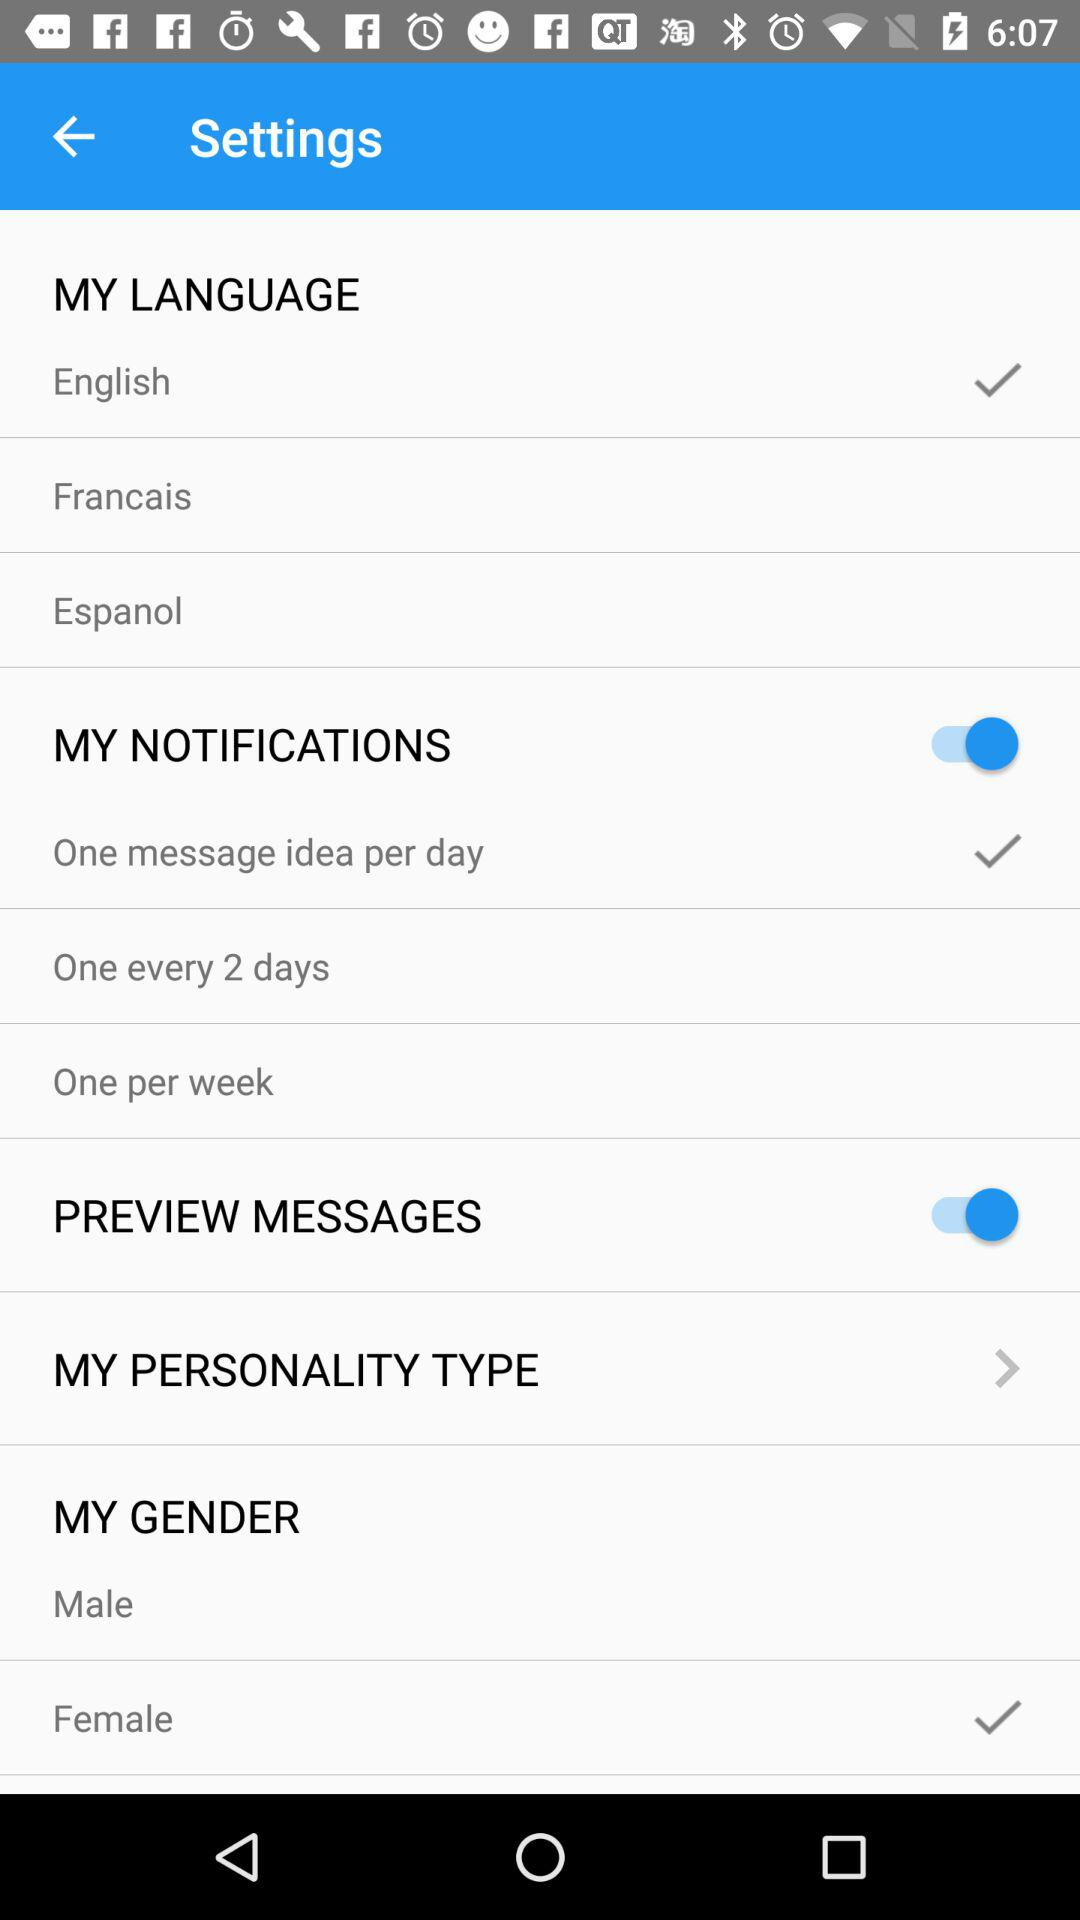Which language is selected? The selected language is English. 